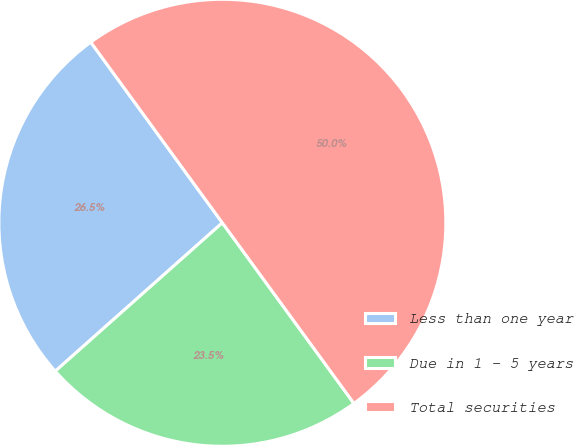Convert chart to OTSL. <chart><loc_0><loc_0><loc_500><loc_500><pie_chart><fcel>Less than one year<fcel>Due in 1 - 5 years<fcel>Total securities<nl><fcel>26.54%<fcel>23.46%<fcel>50.0%<nl></chart> 